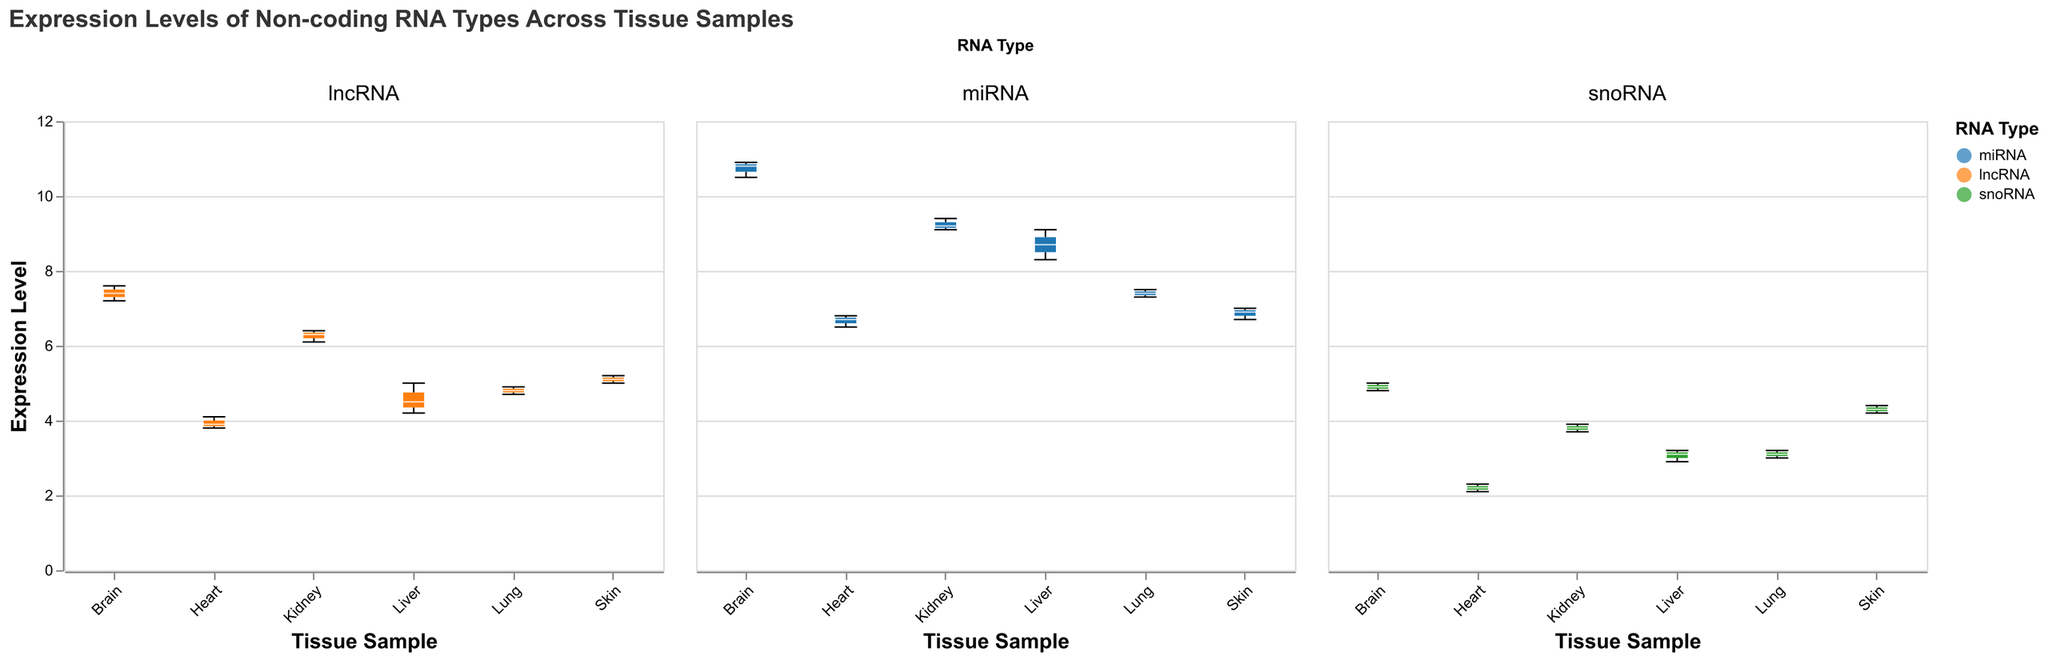What is the median expression level of miRNA in Brain samples? By examining the median line inside the box for the Brain samples under the miRNA column, we can see it intersects close to 10.8.
Answer: 10.8 Which tissue sample has the highest median expression level of lncRNA? By comparing the median lines within each box in the lncRNA column, the Brain sample has the highest median line.
Answer: Brain Is the median expression level of miRNA in the Liver higher than in the Heart? Yes, the median line for miRNA in the Liver column is higher than the median line for miRNA in the Heart column.
Answer: Yes What is the range of expression levels for snoRNA in the Skin? The range is determined by the minimum and maximum extent of the notches for snoRNA in the Skin column. The minimum is about 4.2 and the maximum is about 4.4.
Answer: 4.2 to 4.4 How does the expression variability of lncRNA in the Kidney compare to that in the Lung? By comparing the boxplot widths for lncRNA in the Kidney and Lung columns, the Kidney has a slightly narrower box, indicating less variability.
Answer: Less variability in Kidney Are there outliers present in the miRNA expression in the Brain samples? By visually inspecting the box plot for Brain under miRNA, no individual points are visible outside the whiskers, indicating no outliers.
Answer: No Which tissue sample shows the least variability in miRNA expression levels? The least variability is shown by the sample with the narrowest box plot under miRNA. The Heart sample has the narrowest box plot for miRNA.
Answer: Heart What is the median expression level of snoRNA in the Lung samples? By examining the median line inside the box for the Lung samples under the snoRNA column, it intersects close to 3.1.
Answer: 3.1 Which RNA type shows the most expression in the Heart samples? By comparing the median lines within each RNA type column for the Heart samples, miRNA has the highest median line.
Answer: miRNA What are the highest and lowest median expression levels for lncRNA across all tissue samples? By comparing the median lines for lncRNA across all tissues, the Brain has the highest median (around 7.4) and the Heart has the lowest median (around 3.9).
Answer: Highest: Brain, Lowest: Heart 